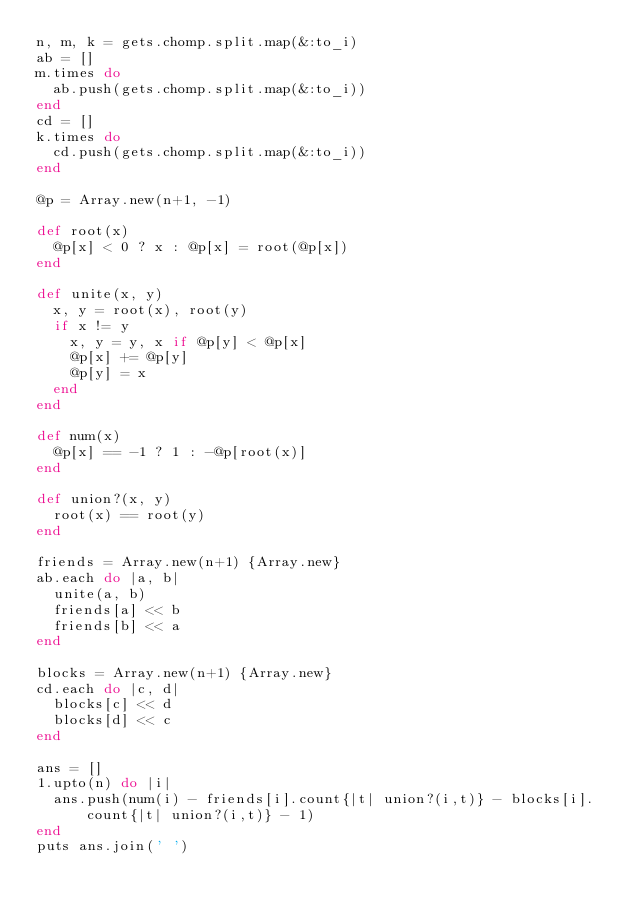Convert code to text. <code><loc_0><loc_0><loc_500><loc_500><_Ruby_>n, m, k = gets.chomp.split.map(&:to_i)
ab = []
m.times do
  ab.push(gets.chomp.split.map(&:to_i))
end
cd = []
k.times do
  cd.push(gets.chomp.split.map(&:to_i))
end

@p = Array.new(n+1, -1)

def root(x)
  @p[x] < 0 ? x : @p[x] = root(@p[x])
end

def unite(x, y)
  x, y = root(x), root(y)
  if x != y
    x, y = y, x if @p[y] < @p[x]
    @p[x] += @p[y]
    @p[y] = x
  end
end

def num(x)
  @p[x] == -1 ? 1 : -@p[root(x)]
end

def union?(x, y)
  root(x) == root(y)
end

friends = Array.new(n+1) {Array.new}
ab.each do |a, b|
  unite(a, b)
  friends[a] << b
  friends[b] << a
end

blocks = Array.new(n+1) {Array.new}
cd.each do |c, d|
  blocks[c] << d
  blocks[d] << c
end

ans = []
1.upto(n) do |i|
  ans.push(num(i) - friends[i].count{|t| union?(i,t)} - blocks[i].count{|t| union?(i,t)} - 1)
end
puts ans.join(' ')
</code> 